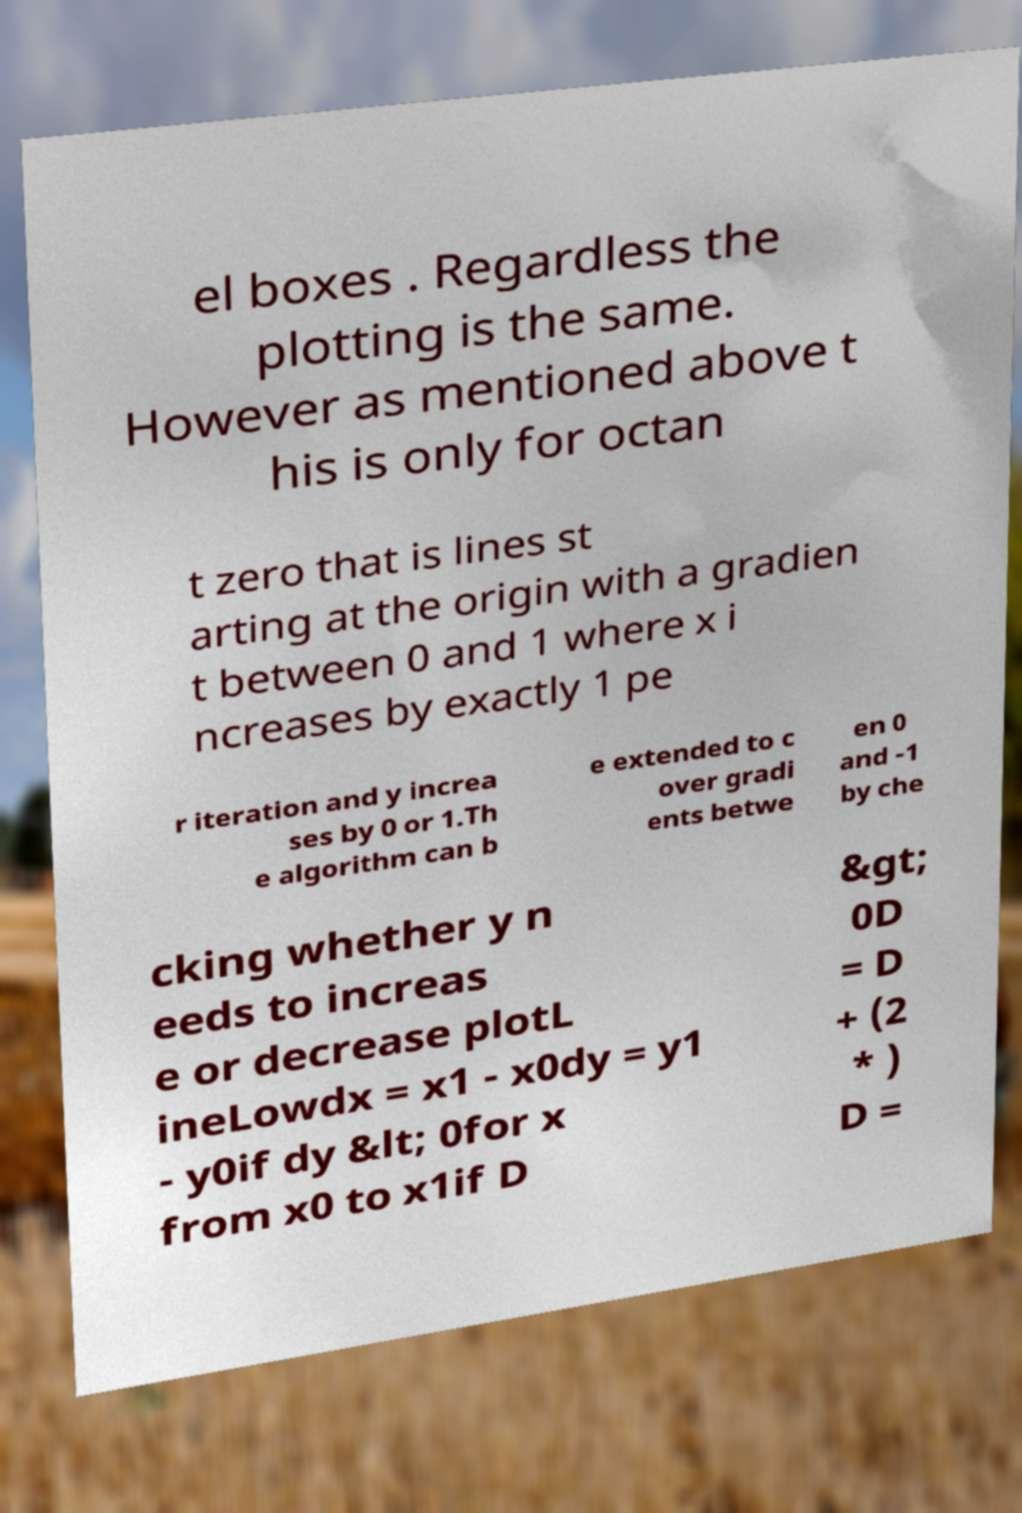I need the written content from this picture converted into text. Can you do that? el boxes . Regardless the plotting is the same. However as mentioned above t his is only for octan t zero that is lines st arting at the origin with a gradien t between 0 and 1 where x i ncreases by exactly 1 pe r iteration and y increa ses by 0 or 1.Th e algorithm can b e extended to c over gradi ents betwe en 0 and -1 by che cking whether y n eeds to increas e or decrease plotL ineLowdx = x1 - x0dy = y1 - y0if dy &lt; 0for x from x0 to x1if D &gt; 0D = D + (2 * ) D = 